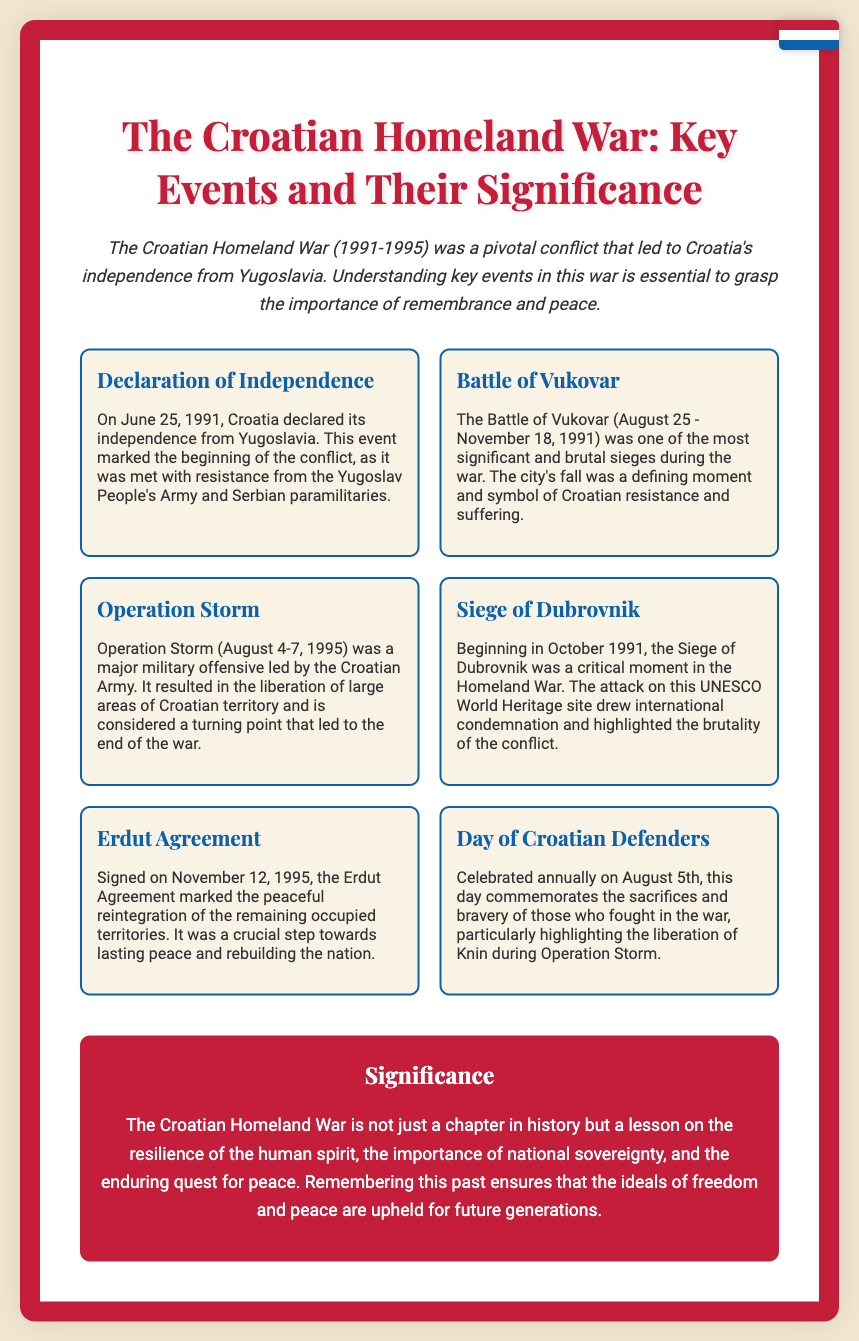What date did Croatia declare independence? The document states that Croatia declared its independence on June 25, 1991.
Answer: June 25, 1991 What event marked the beginning of the Croatian Homeland War? According to the document, the declaration of independence marked the beginning of the conflict.
Answer: Declaration of Independence Which city was besieged during the Battle of Vukovar? The document specifies that the Battle of Vukovar took place in the city of Vukovar.
Answer: Vukovar What significant operation occurred from August 4-7, 1995? The document mentions Operation Storm as the major military offensive during these dates.
Answer: Operation Storm What agreement was signed on November 12, 1995? The document refers to the Erdut Agreement as the agreement signed on this date.
Answer: Erdut Agreement Why is August 5th significant in Croatian history? The document states that August 5th is celebrated as the Day of Croatian Defenders, commemorating sacrifices in the war.
Answer: Day of Croatian Defenders How does the document describe the significance of the Croatian Homeland War? The document highlights the war's lessons on resilience, sovereignty, and the quest for peace.
Answer: Resilience, sovereignty, and quest for peace What is a key takeaway from the poster regarding remembrance? The document emphasizes that remembering this past ensures the ideals of freedom and peace are upheld.
Answer: Freedom and peace 